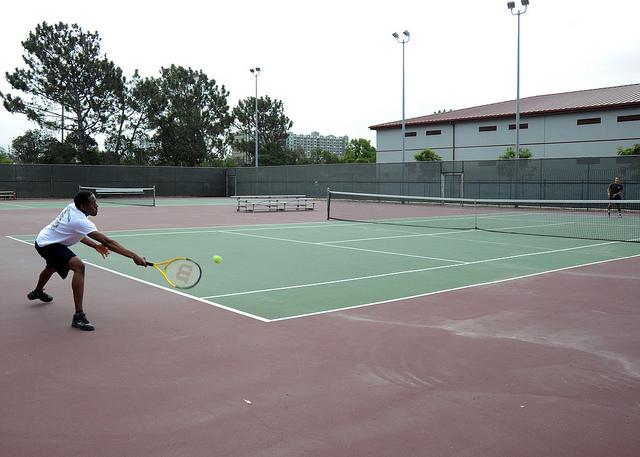How many people are playing?
Concise answer only. 2. Are these grass tennis courts?
Answer briefly. No. Is there a house visible in this picture?
Answer briefly. No. Is there a pool?
Write a very short answer. No. What race is the man playing?
Concise answer only. Tennis. What game is this?
Keep it brief. Tennis. 